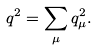<formula> <loc_0><loc_0><loc_500><loc_500>q ^ { 2 } = \sum _ { \mu } q ^ { 2 } _ { \mu } .</formula> 